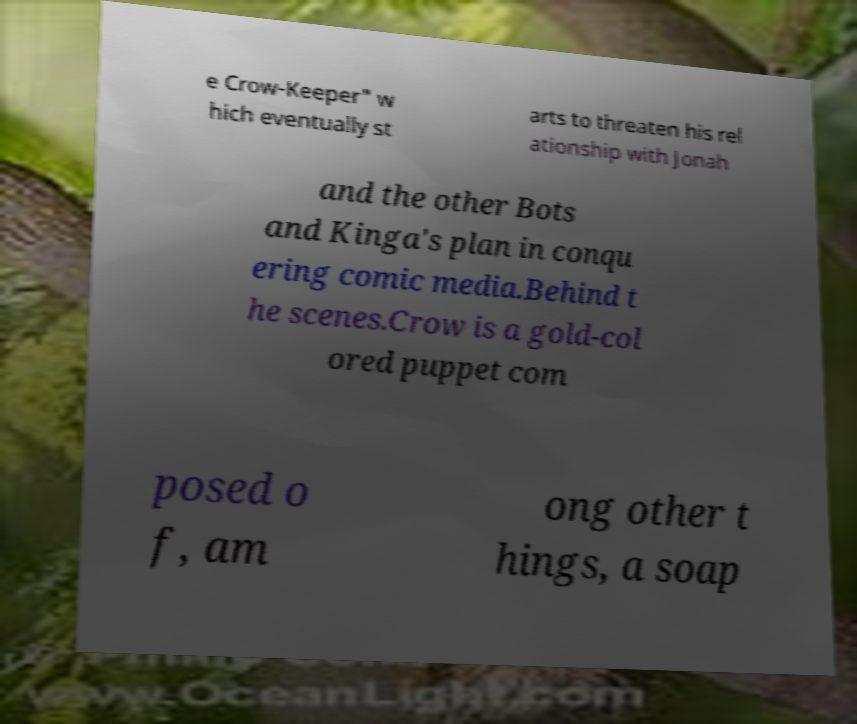What messages or text are displayed in this image? I need them in a readable, typed format. e Crow-Keeper" w hich eventually st arts to threaten his rel ationship with Jonah and the other Bots and Kinga's plan in conqu ering comic media.Behind t he scenes.Crow is a gold-col ored puppet com posed o f, am ong other t hings, a soap 